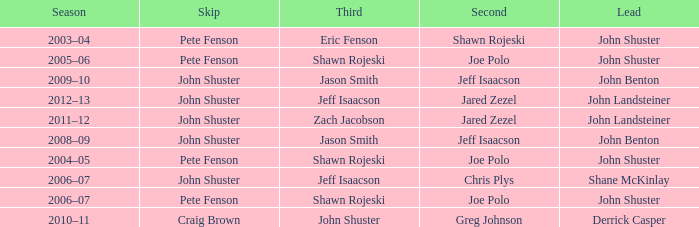Which season has Zach Jacobson in third? 2011–12. 